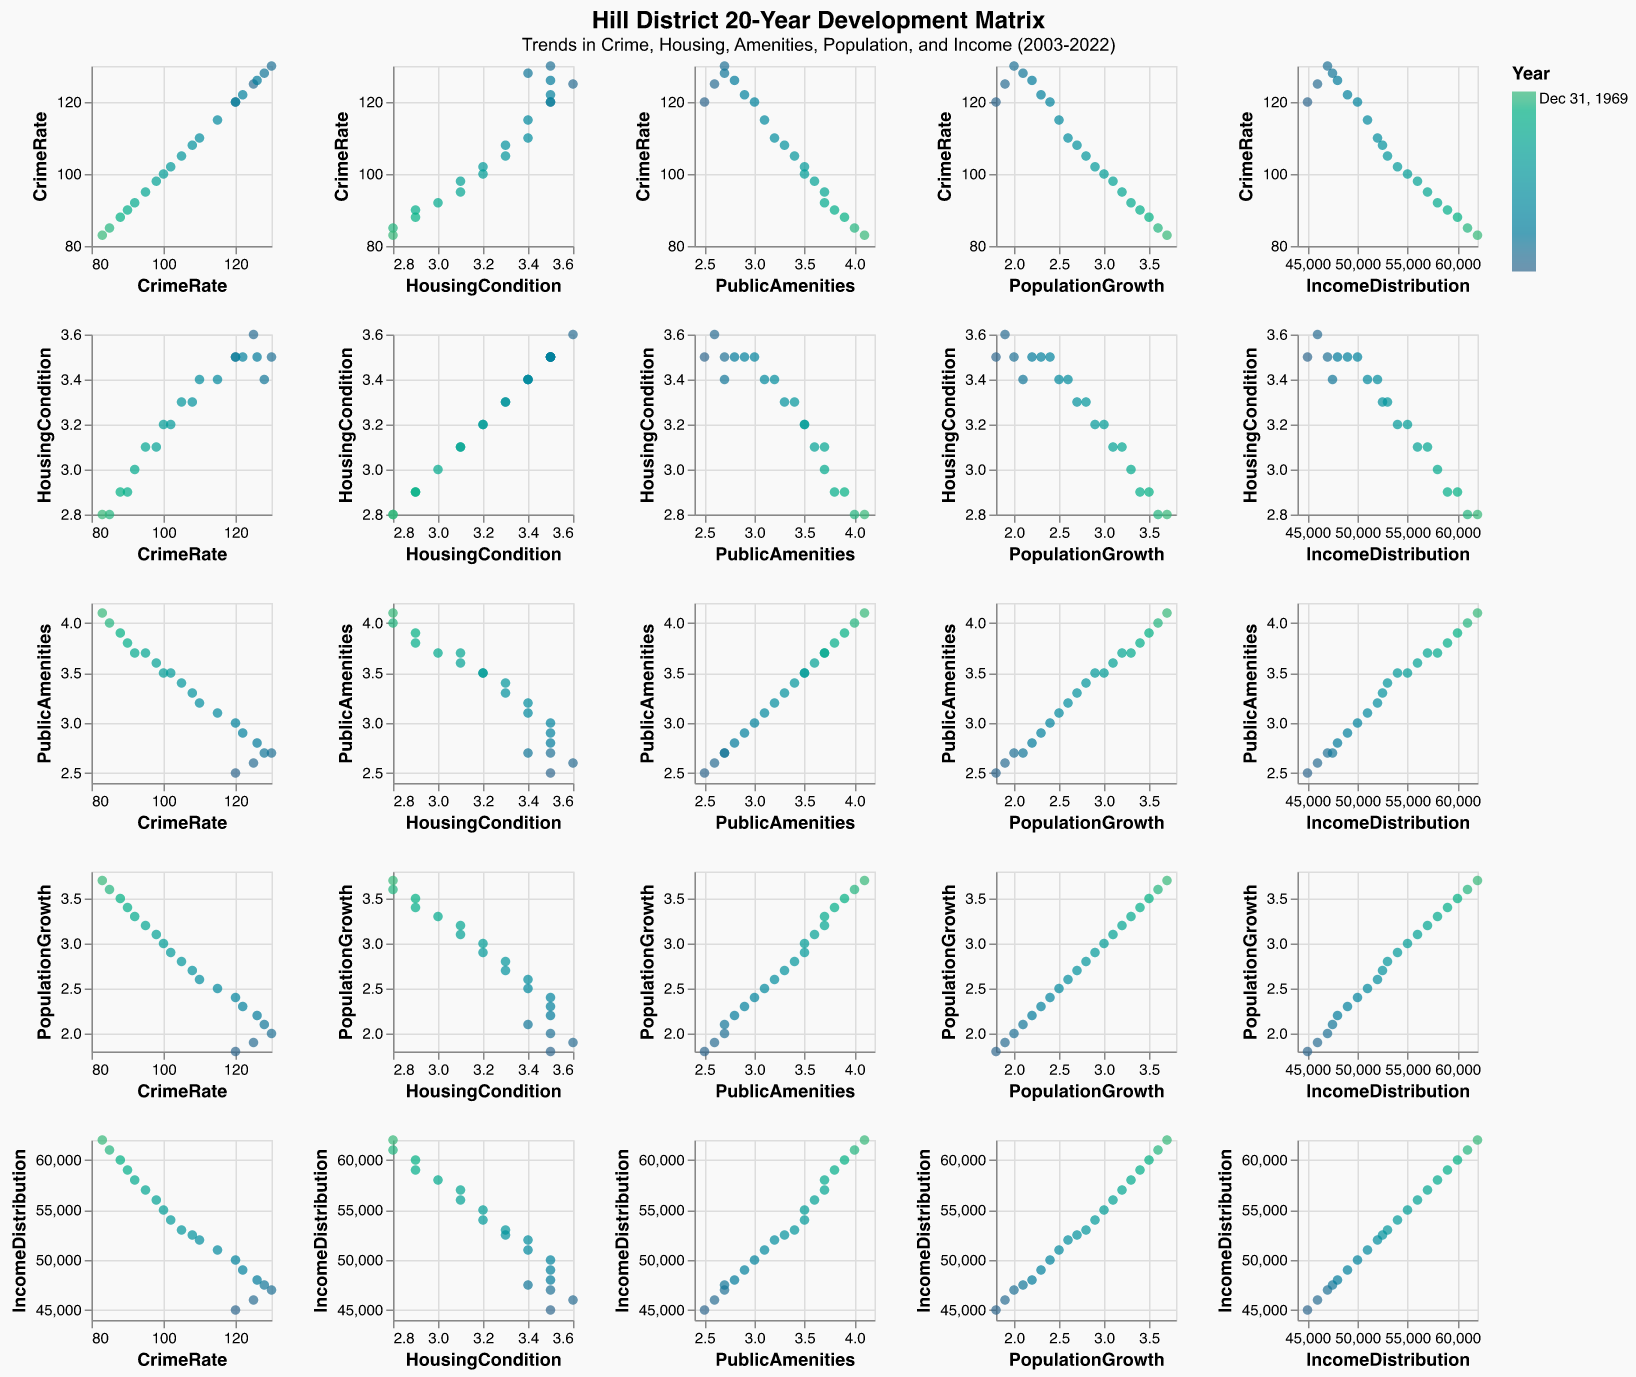How has the CrimeRate evolved from 2003 to 2022? Look at the scatter plot for CrimeRate over the years. CrimeRate starts high in 2003 and shows a general declining trend, ending lower in 2022.
Answer: Decreased What is the relationship between PublicAmenities and PopulationGrowth? Look at the scatter plot comparing PublicAmenities and PopulationGrowth. There appears to be a positive correlation: as PublicAmenities increase, PopulationGrowth also increases.
Answer: Positive correlation Which year shows the highest CrimeRate? Look at the scatter plot for CrimeRate over the years. The highest CrimeRate values occur around the early 2000s. The peak is in 2005.
Answer: 2005 Is there a relationship between IncomeDistribution and HousingCondition? Examine the scatter plot comparing IncomeDistribution and HousingCondition. As IncomeDistribution increases, HousingCondition tends to decrease, indicating a possible negative correlation.
Answer: Negative correlation How does PopulationGrowth correlate with CrimeRate? Look at the scatter plot comparing PopulationGrowth and CrimeRate. There is an inverse relationship where higher CrimeRate values correspond to lower PopulationGrowth rates.
Answer: Inverse correlation What is the range of IncomeDistribution from 2003 to 2022? Look at the axis for IncomeDistribution. The lowest value is around 45,000 in 2003, and the highest is around 62,000 in 2022. Therefore, the range is 62,000 - 45,000 = 17,000.
Answer: 17,000 In which year did PublicAmenities surpass a score of 3.0? Look at the scatter plot for PublicAmenities over the years. PublicAmenities first surpassed a score of 3.0 in 2009.
Answer: 2009 Which attribute has the most substantial positive trend over the years? Examine the scatter plots with "Years" on the X-axis for all attributes. Both PopulationGrowth and IncomeDistribution show distinct positive trends, but IncomeDistribution shows an uninterrupted rising trend.
Answer: IncomeDistribution What can be inferred about the general trend in HousingCondition from 2003 to 2022? Look at the scatter plot for HousingCondition over the years. HousingCondition shows a slight declining trend over the period.
Answer: Slight decline Which attribute shows the least variation over the 20-year period? Examine the scatter plots for all attributes. HousingCondition has the least amount of variation compared to others over the 20 years, staying within a narrow range.
Answer: HousingCondition 